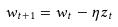<formula> <loc_0><loc_0><loc_500><loc_500>w _ { t + 1 } = w _ { t } - \eta z _ { t }</formula> 